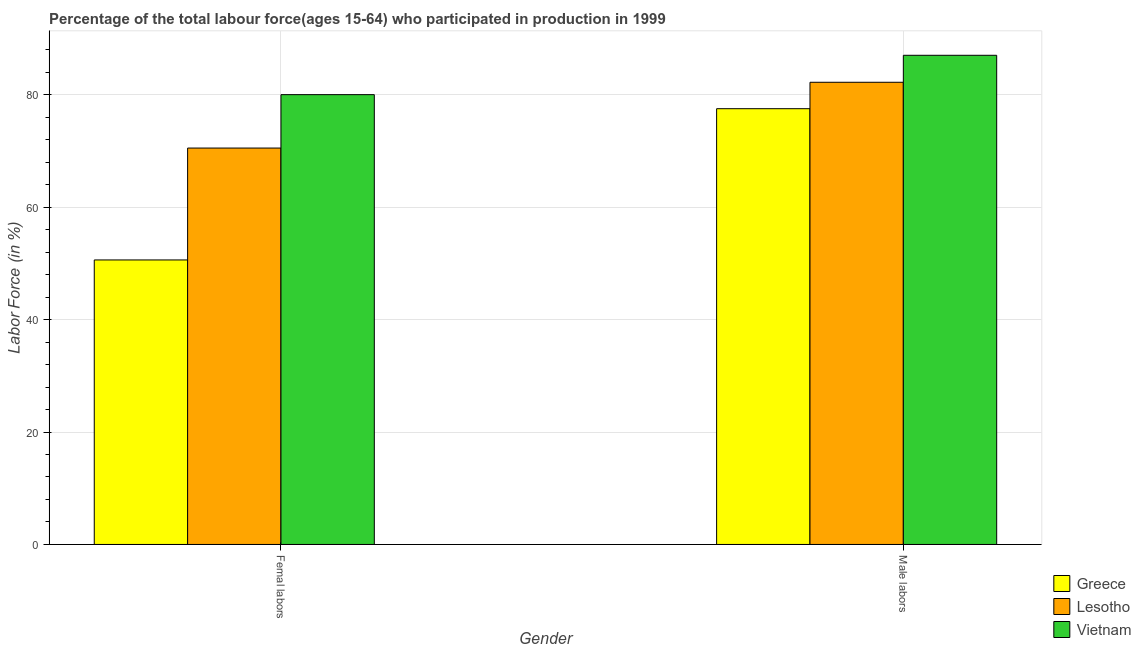Are the number of bars on each tick of the X-axis equal?
Make the answer very short. Yes. How many bars are there on the 1st tick from the left?
Keep it short and to the point. 3. How many bars are there on the 2nd tick from the right?
Make the answer very short. 3. What is the label of the 2nd group of bars from the left?
Give a very brief answer. Male labors. Across all countries, what is the minimum percentage of female labor force?
Provide a succinct answer. 50.6. In which country was the percentage of male labour force maximum?
Your answer should be compact. Vietnam. What is the total percentage of male labour force in the graph?
Ensure brevity in your answer.  246.7. What is the difference between the percentage of male labour force in Greece and that in Vietnam?
Your response must be concise. -9.5. What is the average percentage of female labor force per country?
Your answer should be compact. 67.03. What is the difference between the percentage of female labor force and percentage of male labour force in Vietnam?
Offer a very short reply. -7. What is the ratio of the percentage of female labor force in Greece to that in Vietnam?
Keep it short and to the point. 0.63. Is the percentage of male labour force in Lesotho less than that in Vietnam?
Offer a very short reply. Yes. What does the 3rd bar from the left in Femal labors represents?
Your response must be concise. Vietnam. What does the 1st bar from the right in Male labors represents?
Provide a short and direct response. Vietnam. How many bars are there?
Make the answer very short. 6. Are all the bars in the graph horizontal?
Your answer should be compact. No. How many countries are there in the graph?
Make the answer very short. 3. Does the graph contain any zero values?
Make the answer very short. No. Does the graph contain grids?
Ensure brevity in your answer.  Yes. Where does the legend appear in the graph?
Your answer should be very brief. Bottom right. How are the legend labels stacked?
Your answer should be compact. Vertical. What is the title of the graph?
Keep it short and to the point. Percentage of the total labour force(ages 15-64) who participated in production in 1999. What is the Labor Force (in %) in Greece in Femal labors?
Give a very brief answer. 50.6. What is the Labor Force (in %) in Lesotho in Femal labors?
Offer a very short reply. 70.5. What is the Labor Force (in %) in Vietnam in Femal labors?
Provide a short and direct response. 80. What is the Labor Force (in %) in Greece in Male labors?
Ensure brevity in your answer.  77.5. What is the Labor Force (in %) of Lesotho in Male labors?
Give a very brief answer. 82.2. Across all Gender, what is the maximum Labor Force (in %) of Greece?
Ensure brevity in your answer.  77.5. Across all Gender, what is the maximum Labor Force (in %) of Lesotho?
Make the answer very short. 82.2. Across all Gender, what is the minimum Labor Force (in %) in Greece?
Your answer should be very brief. 50.6. Across all Gender, what is the minimum Labor Force (in %) in Lesotho?
Your answer should be compact. 70.5. What is the total Labor Force (in %) of Greece in the graph?
Your answer should be compact. 128.1. What is the total Labor Force (in %) of Lesotho in the graph?
Make the answer very short. 152.7. What is the total Labor Force (in %) of Vietnam in the graph?
Offer a very short reply. 167. What is the difference between the Labor Force (in %) of Greece in Femal labors and that in Male labors?
Provide a succinct answer. -26.9. What is the difference between the Labor Force (in %) in Lesotho in Femal labors and that in Male labors?
Keep it short and to the point. -11.7. What is the difference between the Labor Force (in %) of Greece in Femal labors and the Labor Force (in %) of Lesotho in Male labors?
Your response must be concise. -31.6. What is the difference between the Labor Force (in %) in Greece in Femal labors and the Labor Force (in %) in Vietnam in Male labors?
Your response must be concise. -36.4. What is the difference between the Labor Force (in %) of Lesotho in Femal labors and the Labor Force (in %) of Vietnam in Male labors?
Provide a short and direct response. -16.5. What is the average Labor Force (in %) of Greece per Gender?
Provide a succinct answer. 64.05. What is the average Labor Force (in %) of Lesotho per Gender?
Your response must be concise. 76.35. What is the average Labor Force (in %) of Vietnam per Gender?
Offer a terse response. 83.5. What is the difference between the Labor Force (in %) of Greece and Labor Force (in %) of Lesotho in Femal labors?
Provide a short and direct response. -19.9. What is the difference between the Labor Force (in %) of Greece and Labor Force (in %) of Vietnam in Femal labors?
Provide a succinct answer. -29.4. What is the difference between the Labor Force (in %) in Lesotho and Labor Force (in %) in Vietnam in Femal labors?
Your answer should be very brief. -9.5. What is the difference between the Labor Force (in %) of Greece and Labor Force (in %) of Lesotho in Male labors?
Offer a terse response. -4.7. What is the difference between the Labor Force (in %) of Greece and Labor Force (in %) of Vietnam in Male labors?
Your response must be concise. -9.5. What is the ratio of the Labor Force (in %) of Greece in Femal labors to that in Male labors?
Provide a short and direct response. 0.65. What is the ratio of the Labor Force (in %) in Lesotho in Femal labors to that in Male labors?
Your response must be concise. 0.86. What is the ratio of the Labor Force (in %) of Vietnam in Femal labors to that in Male labors?
Your answer should be very brief. 0.92. What is the difference between the highest and the second highest Labor Force (in %) in Greece?
Provide a succinct answer. 26.9. What is the difference between the highest and the lowest Labor Force (in %) of Greece?
Keep it short and to the point. 26.9. What is the difference between the highest and the lowest Labor Force (in %) of Vietnam?
Offer a very short reply. 7. 